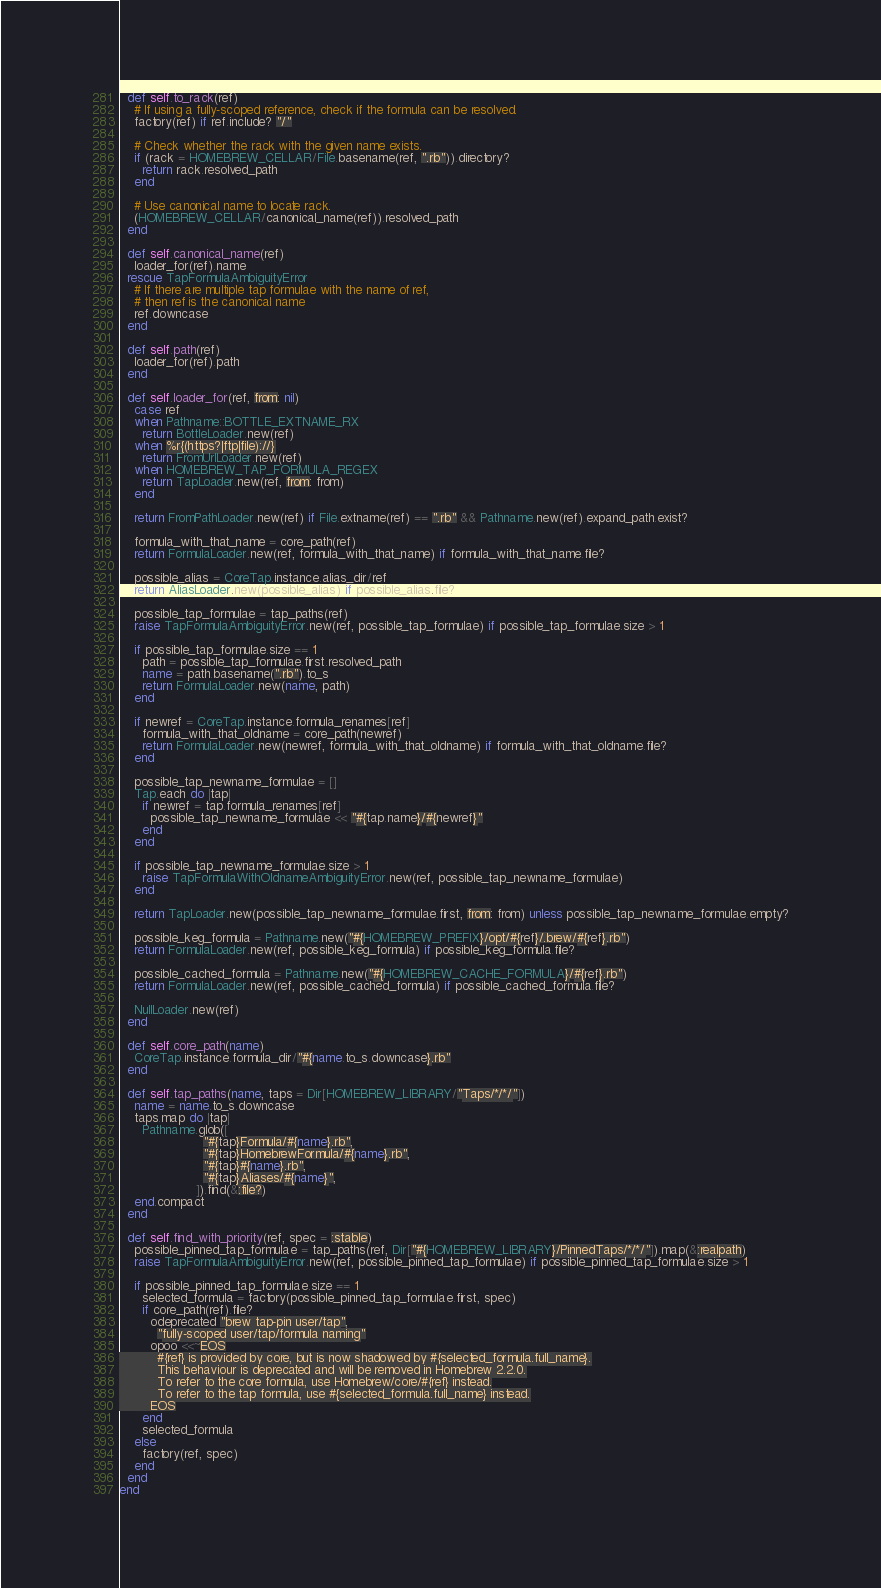<code> <loc_0><loc_0><loc_500><loc_500><_Ruby_>  def self.to_rack(ref)
    # If using a fully-scoped reference, check if the formula can be resolved.
    factory(ref) if ref.include? "/"

    # Check whether the rack with the given name exists.
    if (rack = HOMEBREW_CELLAR/File.basename(ref, ".rb")).directory?
      return rack.resolved_path
    end

    # Use canonical name to locate rack.
    (HOMEBREW_CELLAR/canonical_name(ref)).resolved_path
  end

  def self.canonical_name(ref)
    loader_for(ref).name
  rescue TapFormulaAmbiguityError
    # If there are multiple tap formulae with the name of ref,
    # then ref is the canonical name
    ref.downcase
  end

  def self.path(ref)
    loader_for(ref).path
  end

  def self.loader_for(ref, from: nil)
    case ref
    when Pathname::BOTTLE_EXTNAME_RX
      return BottleLoader.new(ref)
    when %r{(https?|ftp|file)://}
      return FromUrlLoader.new(ref)
    when HOMEBREW_TAP_FORMULA_REGEX
      return TapLoader.new(ref, from: from)
    end

    return FromPathLoader.new(ref) if File.extname(ref) == ".rb" && Pathname.new(ref).expand_path.exist?

    formula_with_that_name = core_path(ref)
    return FormulaLoader.new(ref, formula_with_that_name) if formula_with_that_name.file?

    possible_alias = CoreTap.instance.alias_dir/ref
    return AliasLoader.new(possible_alias) if possible_alias.file?

    possible_tap_formulae = tap_paths(ref)
    raise TapFormulaAmbiguityError.new(ref, possible_tap_formulae) if possible_tap_formulae.size > 1

    if possible_tap_formulae.size == 1
      path = possible_tap_formulae.first.resolved_path
      name = path.basename(".rb").to_s
      return FormulaLoader.new(name, path)
    end

    if newref = CoreTap.instance.formula_renames[ref]
      formula_with_that_oldname = core_path(newref)
      return FormulaLoader.new(newref, formula_with_that_oldname) if formula_with_that_oldname.file?
    end

    possible_tap_newname_formulae = []
    Tap.each do |tap|
      if newref = tap.formula_renames[ref]
        possible_tap_newname_formulae << "#{tap.name}/#{newref}"
      end
    end

    if possible_tap_newname_formulae.size > 1
      raise TapFormulaWithOldnameAmbiguityError.new(ref, possible_tap_newname_formulae)
    end

    return TapLoader.new(possible_tap_newname_formulae.first, from: from) unless possible_tap_newname_formulae.empty?

    possible_keg_formula = Pathname.new("#{HOMEBREW_PREFIX}/opt/#{ref}/.brew/#{ref}.rb")
    return FormulaLoader.new(ref, possible_keg_formula) if possible_keg_formula.file?

    possible_cached_formula = Pathname.new("#{HOMEBREW_CACHE_FORMULA}/#{ref}.rb")
    return FormulaLoader.new(ref, possible_cached_formula) if possible_cached_formula.file?

    NullLoader.new(ref)
  end

  def self.core_path(name)
    CoreTap.instance.formula_dir/"#{name.to_s.downcase}.rb"
  end

  def self.tap_paths(name, taps = Dir[HOMEBREW_LIBRARY/"Taps/*/*/"])
    name = name.to_s.downcase
    taps.map do |tap|
      Pathname.glob([
                      "#{tap}Formula/#{name}.rb",
                      "#{tap}HomebrewFormula/#{name}.rb",
                      "#{tap}#{name}.rb",
                      "#{tap}Aliases/#{name}",
                    ]).find(&:file?)
    end.compact
  end

  def self.find_with_priority(ref, spec = :stable)
    possible_pinned_tap_formulae = tap_paths(ref, Dir["#{HOMEBREW_LIBRARY}/PinnedTaps/*/*/"]).map(&:realpath)
    raise TapFormulaAmbiguityError.new(ref, possible_pinned_tap_formulae) if possible_pinned_tap_formulae.size > 1

    if possible_pinned_tap_formulae.size == 1
      selected_formula = factory(possible_pinned_tap_formulae.first, spec)
      if core_path(ref).file?
        odeprecated "brew tap-pin user/tap",
          "fully-scoped user/tap/formula naming"
        opoo <<~EOS
          #{ref} is provided by core, but is now shadowed by #{selected_formula.full_name}.
          This behaviour is deprecated and will be removed in Homebrew 2.2.0.
          To refer to the core formula, use Homebrew/core/#{ref} instead.
          To refer to the tap formula, use #{selected_formula.full_name} instead.
        EOS
      end
      selected_formula
    else
      factory(ref, spec)
    end
  end
end
</code> 